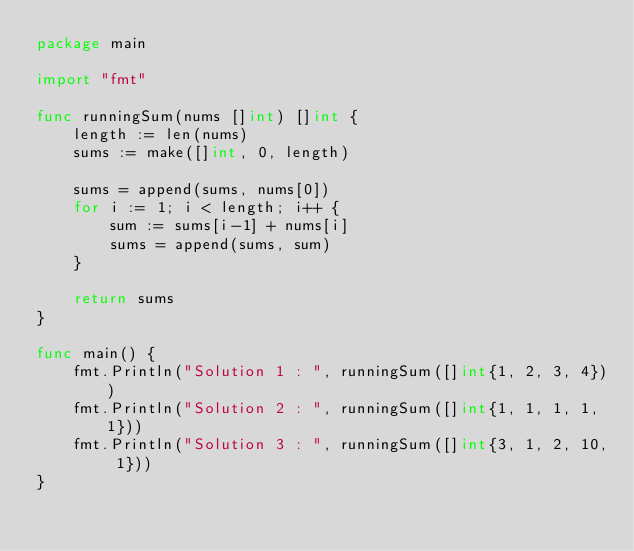Convert code to text. <code><loc_0><loc_0><loc_500><loc_500><_Go_>package main

import "fmt"

func runningSum(nums []int) []int {
	length := len(nums)
	sums := make([]int, 0, length)

	sums = append(sums, nums[0])
	for i := 1; i < length; i++ {
		sum := sums[i-1] + nums[i]
		sums = append(sums, sum)
	}

	return sums
}

func main() {
	fmt.Println("Solution 1 : ", runningSum([]int{1, 2, 3, 4}))
	fmt.Println("Solution 2 : ", runningSum([]int{1, 1, 1, 1, 1}))
	fmt.Println("Solution 3 : ", runningSum([]int{3, 1, 2, 10, 1}))
}
</code> 